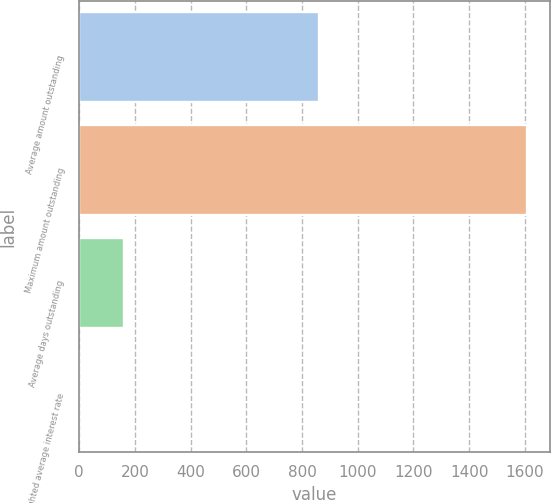Convert chart to OTSL. <chart><loc_0><loc_0><loc_500><loc_500><bar_chart><fcel>Average amount outstanding<fcel>Maximum amount outstanding<fcel>Average days outstanding<fcel>Weighted average interest rate<nl><fcel>861.3<fcel>1608.9<fcel>161.52<fcel>0.7<nl></chart> 